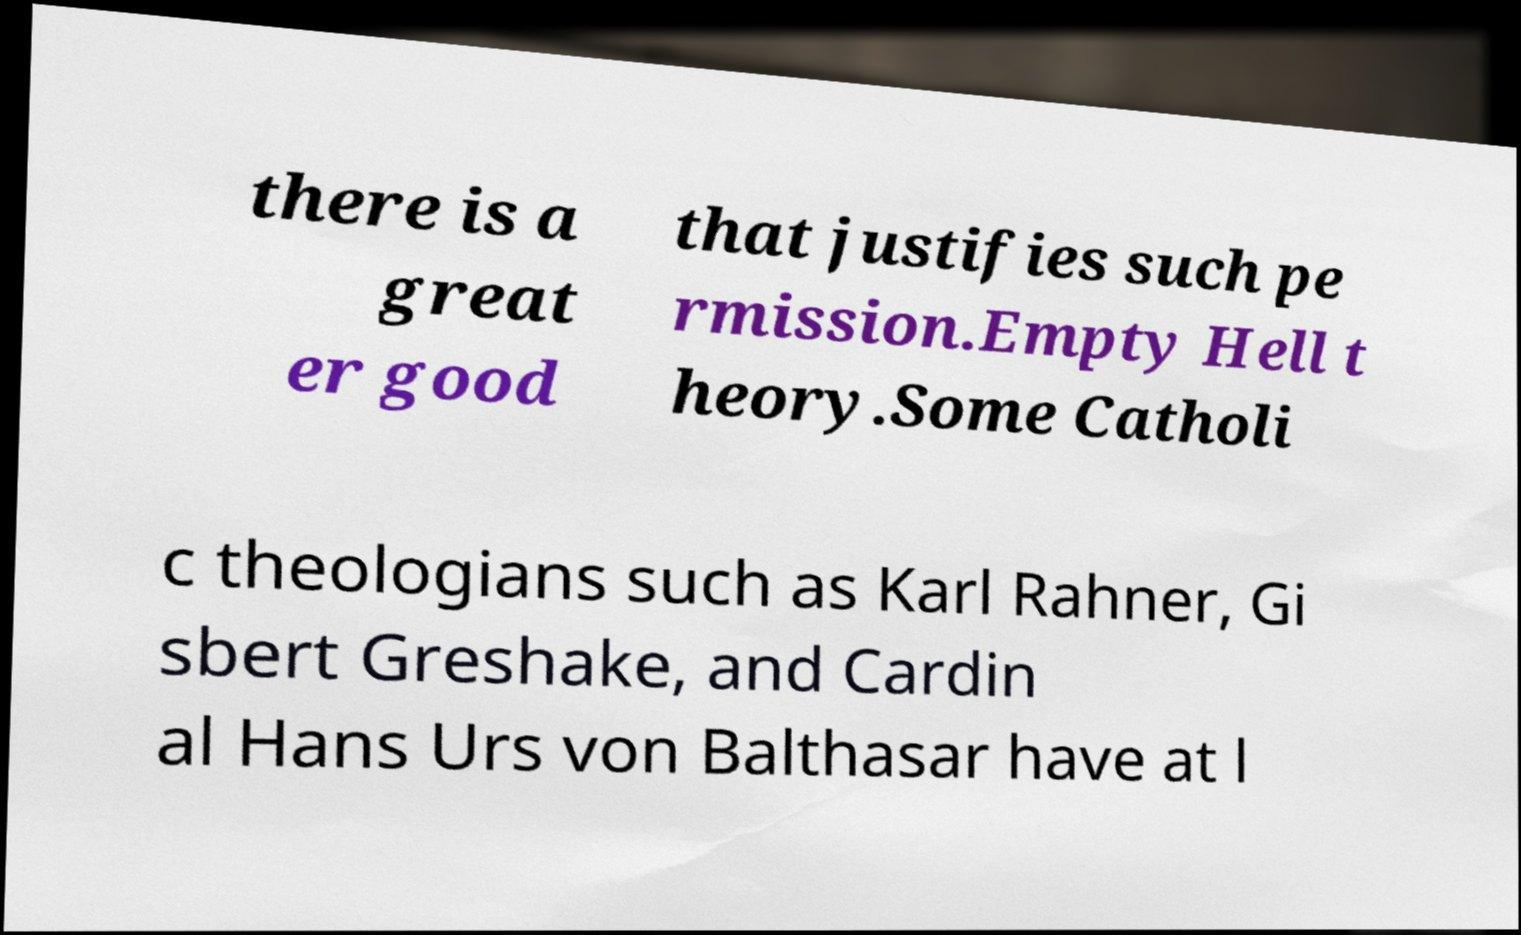I need the written content from this picture converted into text. Can you do that? there is a great er good that justifies such pe rmission.Empty Hell t heory.Some Catholi c theologians such as Karl Rahner, Gi sbert Greshake, and Cardin al Hans Urs von Balthasar have at l 